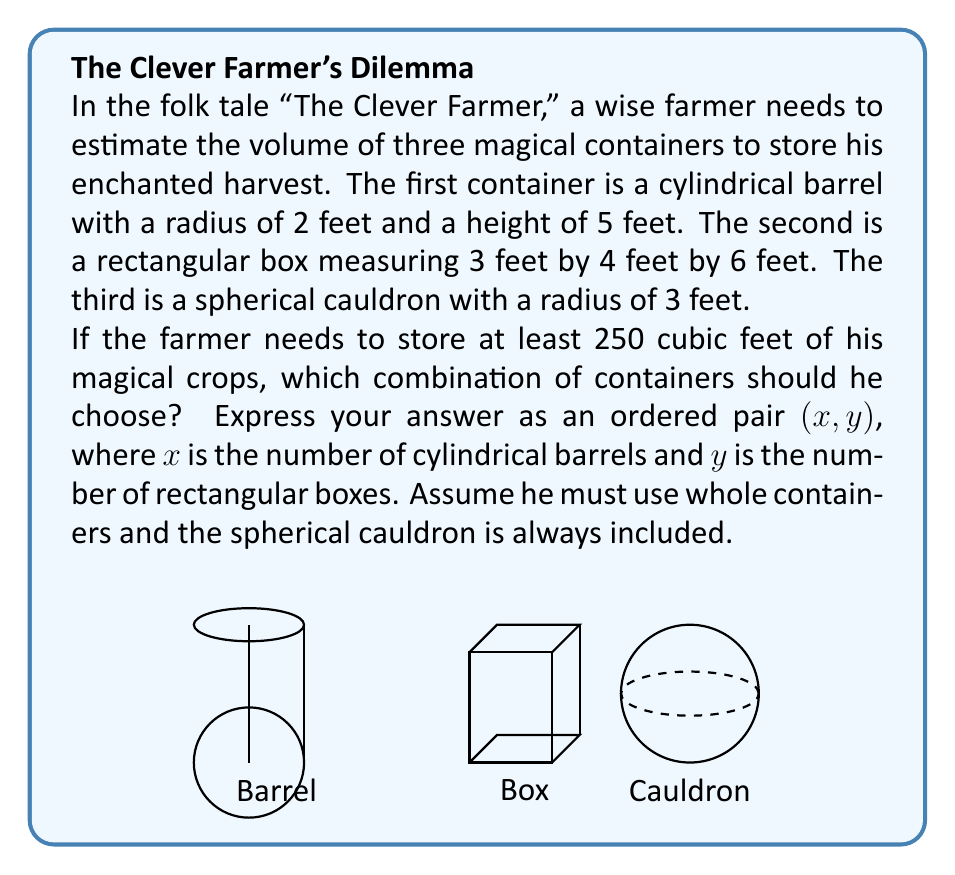Can you answer this question? Let's approach this step-by-step:

1) First, we need to calculate the volume of each container:

   a) Cylindrical barrel: 
      $V_{cylinder} = \pi r^2 h = \pi \cdot 2^2 \cdot 5 = 20\pi \approx 62.83$ cubic feet

   b) Rectangular box:
      $V_{box} = l \cdot w \cdot h = 3 \cdot 4 \cdot 6 = 72$ cubic feet

   c) Spherical cauldron:
      $V_{sphere} = \frac{4}{3}\pi r^3 = \frac{4}{3}\pi \cdot 3^3 = 36\pi \approx 113.10$ cubic feet

2) The spherical cauldron is always included, so we start with 113.10 cubic feet.

3) We need to find combinations of barrels and boxes that, when added to the cauldron, exceed 250 cubic feet:

   $113.10 + 62.83x + 72y \geq 250$

   Where x is the number of barrels and y is the number of boxes.

4) Let's try some combinations:
   - 1 barrel, 1 box: 113.10 + 62.83 + 72 = 247.93 (not enough)
   - 1 barrel, 2 boxes: 113.10 + 62.83 + 144 = 319.93 (enough)
   - 2 barrels, 1 box: 113.10 + 125.66 + 72 = 310.76 (enough)

5) The combination (1, 2) - one barrel and two boxes - is the solution that uses the least number of containers while meeting the volume requirement.
Answer: (1, 2) 